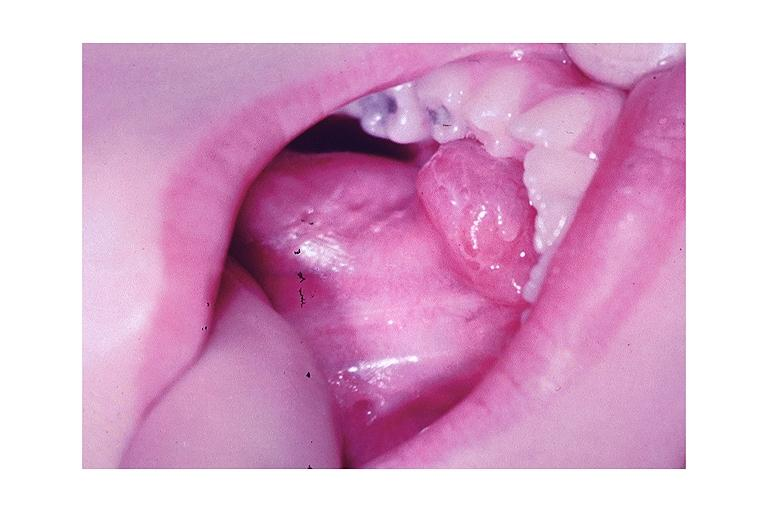what is present?
Answer the question using a single word or phrase. Oral 